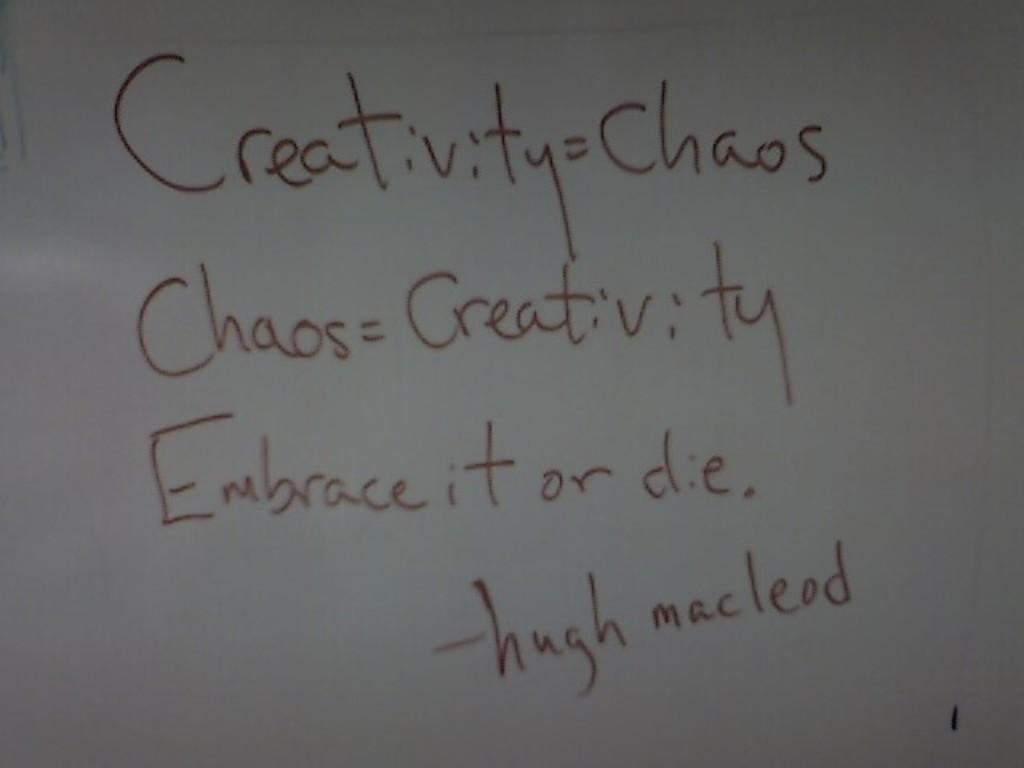<image>
Provide a brief description of the given image. A whiteboard has black writing on it recalling a Hugh Macleod quotation. 